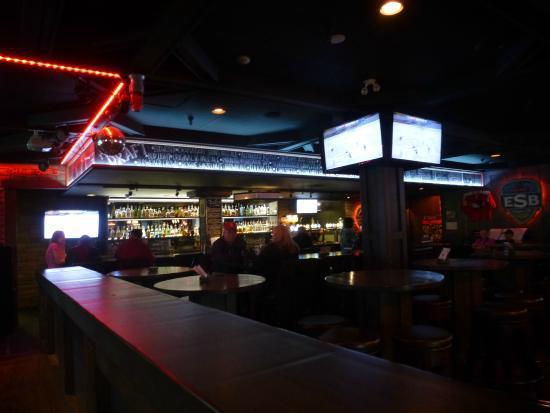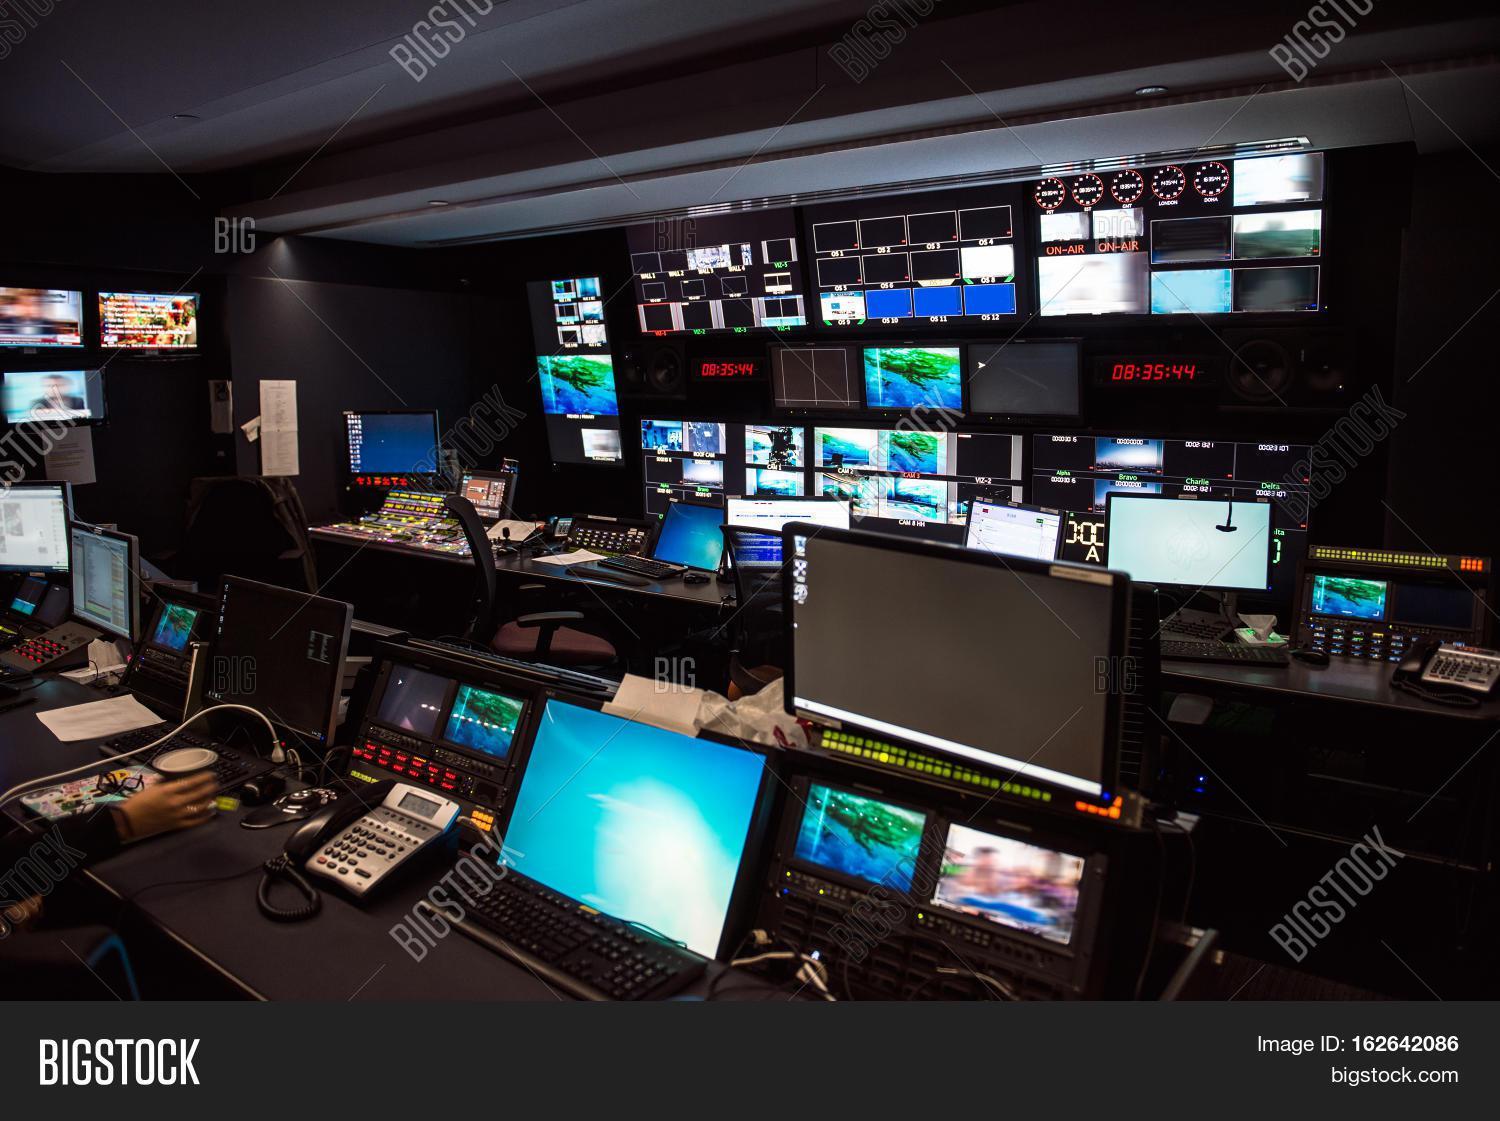The first image is the image on the left, the second image is the image on the right. Assess this claim about the two images: "A person is standing in front of the screen in the image on the left.". Correct or not? Answer yes or no. No. The first image is the image on the left, the second image is the image on the right. Evaluate the accuracy of this statement regarding the images: "An image shows a silhouetted person surrounded by glowing white light and facing a wall of screens filled with pictures.". Is it true? Answer yes or no. No. 